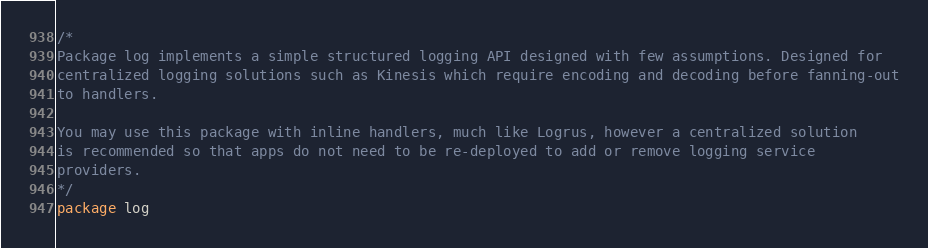Convert code to text. <code><loc_0><loc_0><loc_500><loc_500><_Go_>/*
Package log implements a simple structured logging API designed with few assumptions. Designed for
centralized logging solutions such as Kinesis which require encoding and decoding before fanning-out
to handlers.

You may use this package with inline handlers, much like Logrus, however a centralized solution
is recommended so that apps do not need to be re-deployed to add or remove logging service
providers.
*/
package log
</code> 